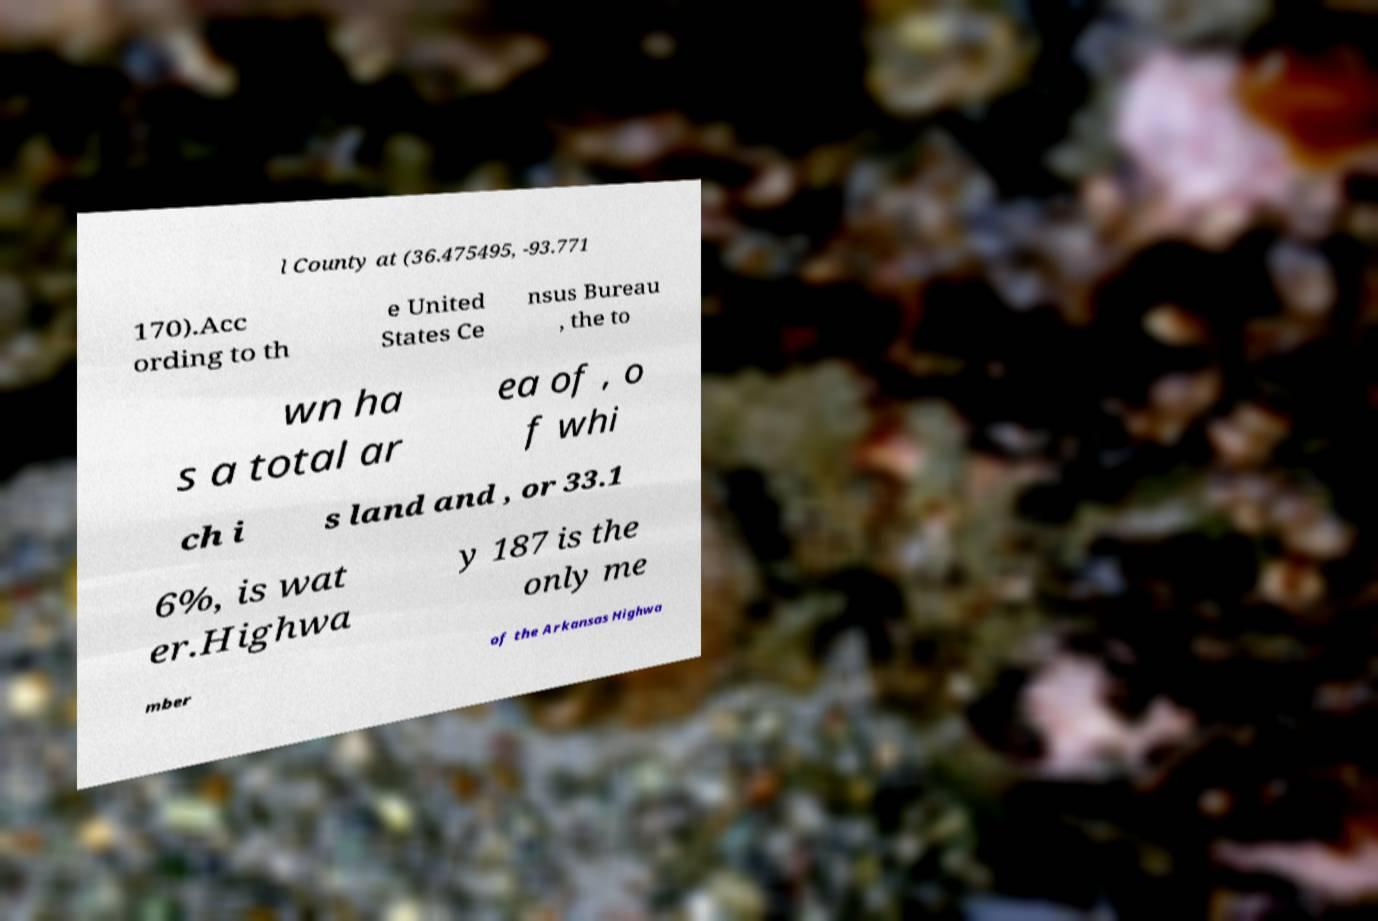I need the written content from this picture converted into text. Can you do that? l County at (36.475495, -93.771 170).Acc ording to th e United States Ce nsus Bureau , the to wn ha s a total ar ea of , o f whi ch i s land and , or 33.1 6%, is wat er.Highwa y 187 is the only me mber of the Arkansas Highwa 